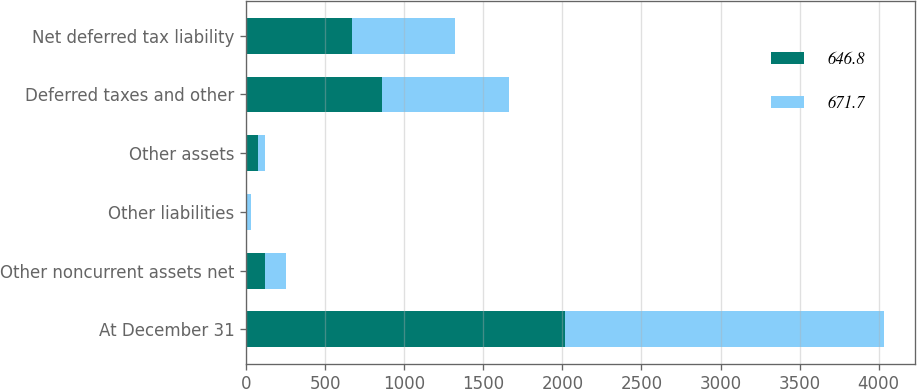Convert chart to OTSL. <chart><loc_0><loc_0><loc_500><loc_500><stacked_bar_chart><ecel><fcel>At December 31<fcel>Other noncurrent assets net<fcel>Other liabilities<fcel>Other assets<fcel>Deferred taxes and other<fcel>Net deferred tax liability<nl><fcel>646.8<fcel>2016<fcel>119.5<fcel>6.3<fcel>74.6<fcel>859.5<fcel>671.7<nl><fcel>671.7<fcel>2015<fcel>135.7<fcel>25<fcel>44.9<fcel>802.4<fcel>646.8<nl></chart> 